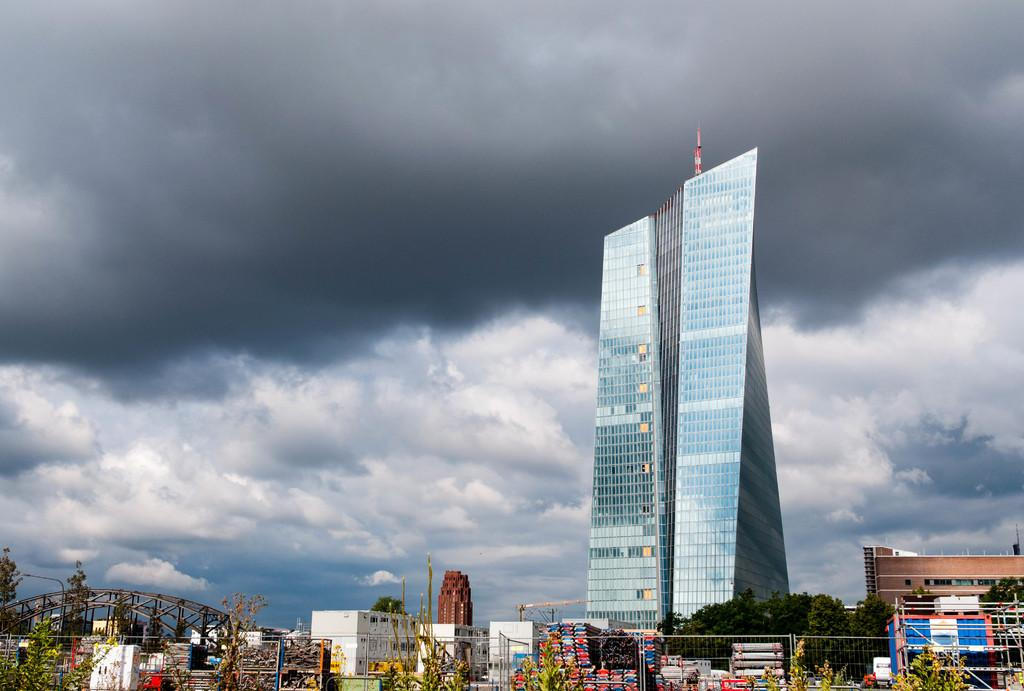What type of structures can be seen in the image? There are buildings in the image. What architectural feature is present in the image? There is an arch in the image. What type of vegetation can be seen in the image? There are plants and trees in the image. What type of barrier is visible in the image? There is a fence in the image. What can be seen in the sky in the image? There are clouds in the sky. Where is the mother toad sitting with her baby toads in the image? There are no toads present in the image. What type of road can be seen in the image? There is no road visible in the image. 